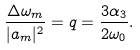Convert formula to latex. <formula><loc_0><loc_0><loc_500><loc_500>\frac { \Delta \omega _ { m } } { | a _ { m } | ^ { 2 } } = q = \frac { 3 \alpha _ { 3 } } { 2 \omega _ { 0 } } .</formula> 